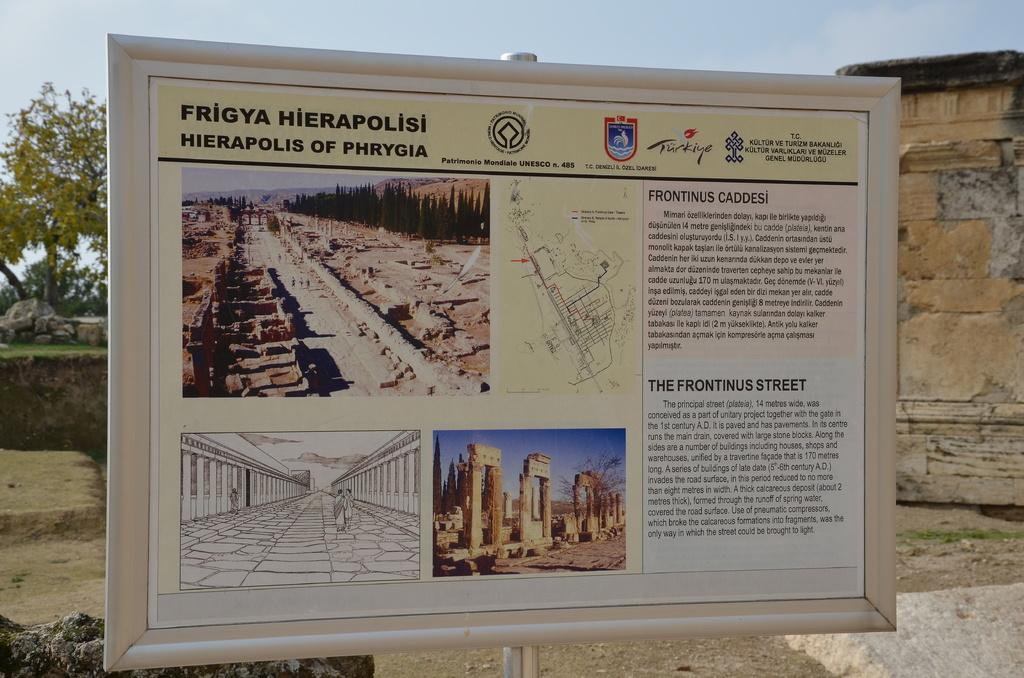<image>
Write a terse but informative summary of the picture. sign post that describes the Frigya Hierapolisis of Phrygia 